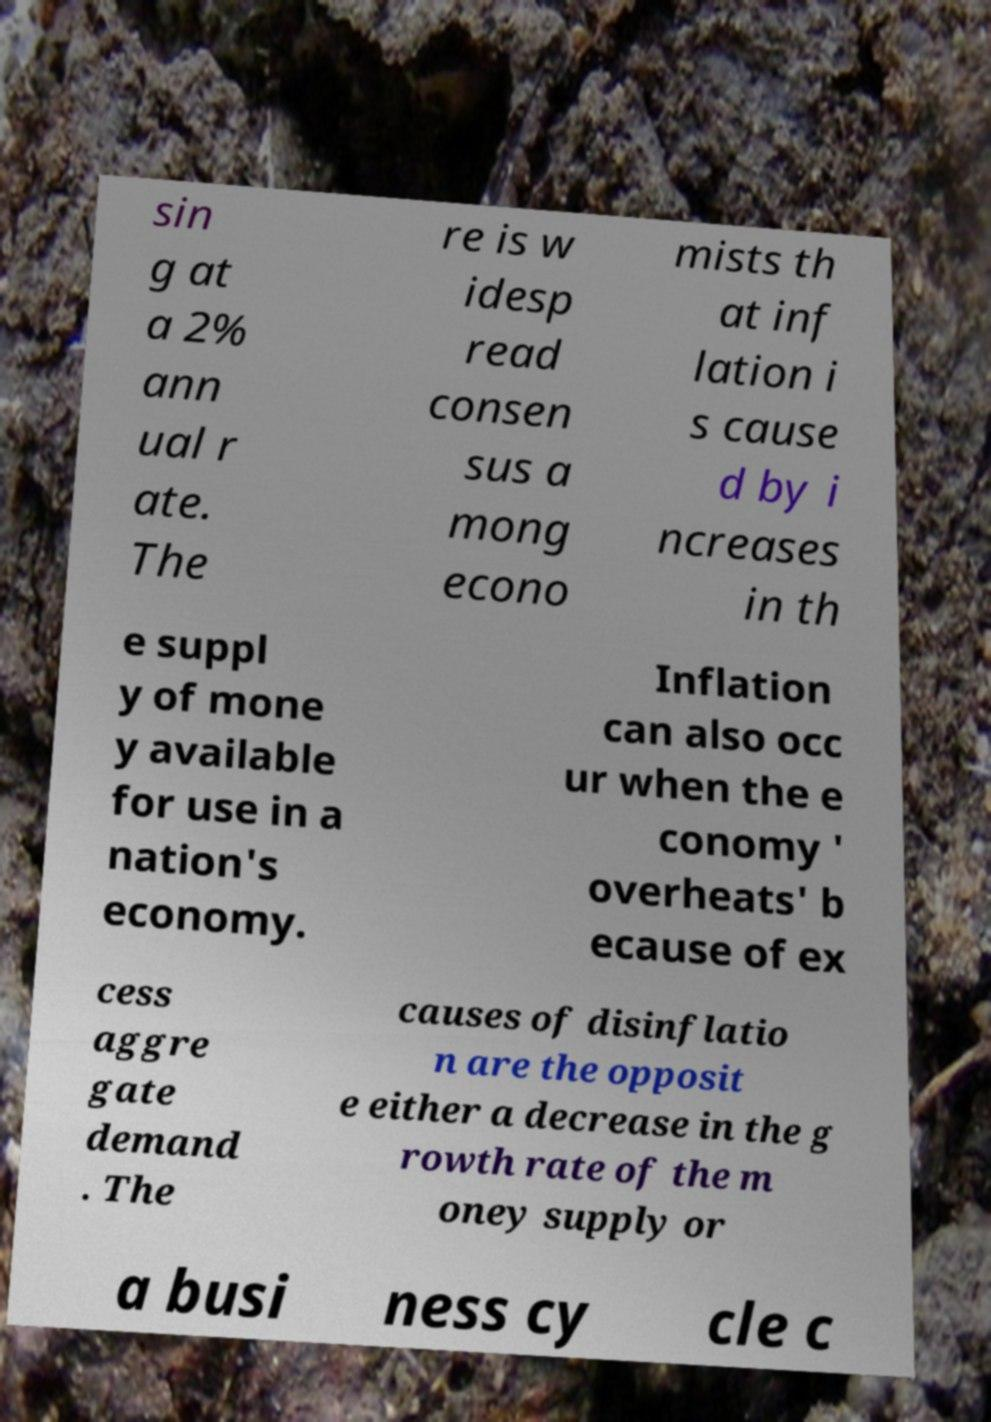Can you accurately transcribe the text from the provided image for me? sin g at a 2% ann ual r ate. The re is w idesp read consen sus a mong econo mists th at inf lation i s cause d by i ncreases in th e suppl y of mone y available for use in a nation's economy. Inflation can also occ ur when the e conomy ' overheats' b ecause of ex cess aggre gate demand . The causes of disinflatio n are the opposit e either a decrease in the g rowth rate of the m oney supply or a busi ness cy cle c 